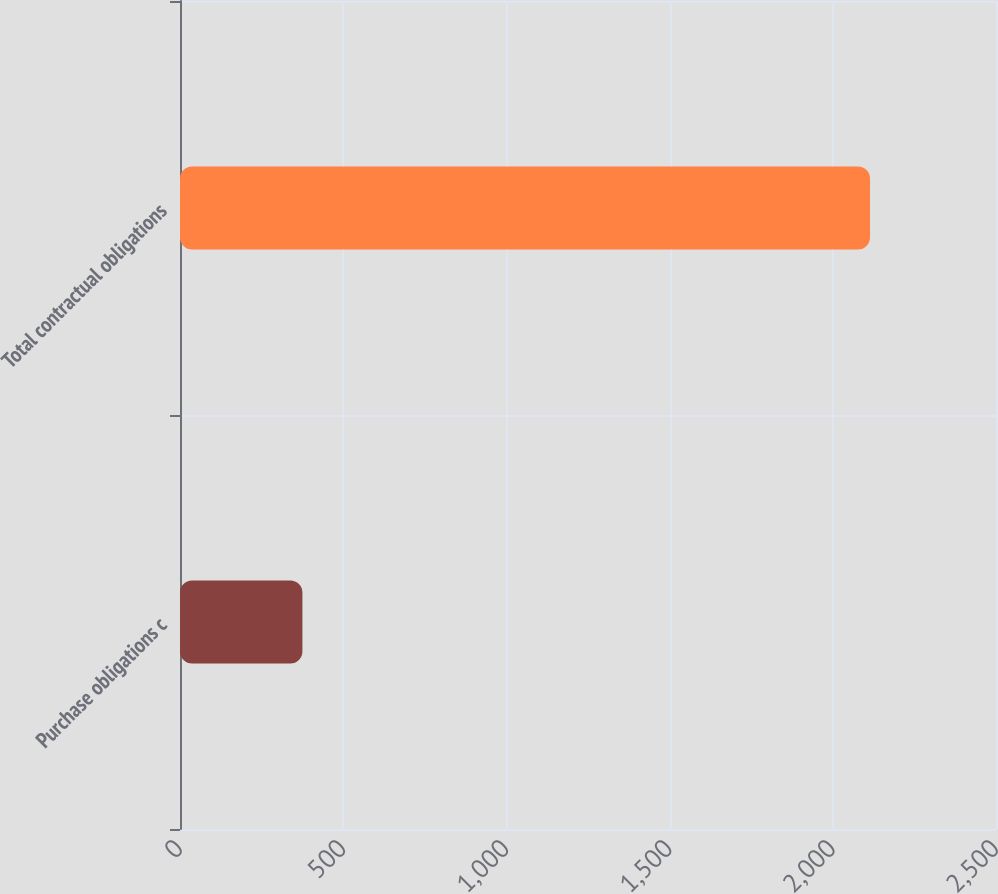Convert chart. <chart><loc_0><loc_0><loc_500><loc_500><bar_chart><fcel>Purchase obligations c<fcel>Total contractual obligations<nl><fcel>375<fcel>2114<nl></chart> 